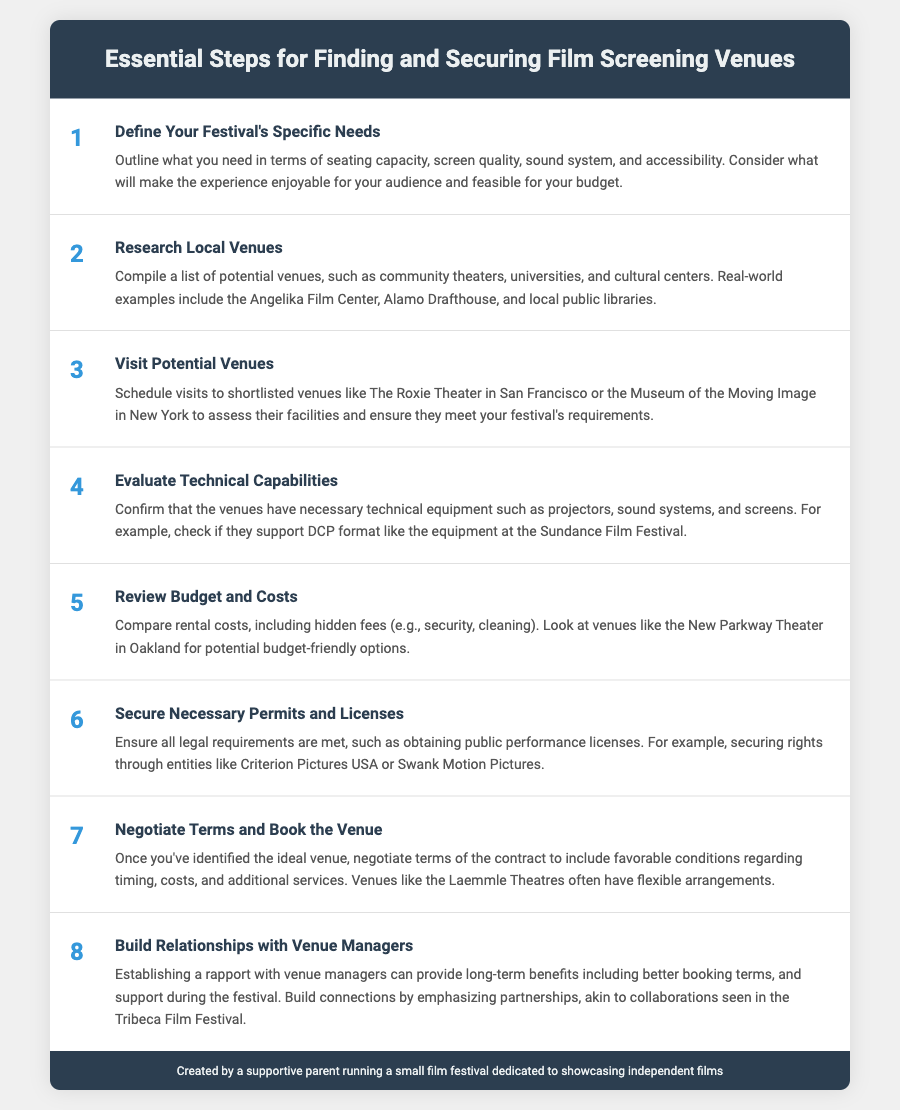What is the first step in securing a film screening venue? The first step listed is to "Define Your Festival's Specific Needs," which involves outlining requirements like seating capacity and sound systems.
Answer: Define Your Festival's Specific Needs Which venue is suggested for evaluating technical capabilities? The document mentions checking if venues support DCP format like the equipment at the Sundance Film Festival for evaluating technical capabilities.
Answer: Sundance Film Festival How many steps are outlined in the document? The document lists a total of eight steps for finding and securing film screening venues.
Answer: 8 What is emphasized as important when negotiating terms with a venue? Negotiating terms should include favorable conditions regarding timing, costs, and additional services, highlighting the importance of flexible arrangements.
Answer: Flexible arrangements What should be secured to meet legal requirements? The document indicates that necessary permits and licenses must be secured, particularly public performance licenses.
Answer: Public performance licenses Which venues were mentioned as potential options for budget-friendly screenings? The New Parkway Theater in Oakland is provided as an example of a budget-friendly venue.
Answer: New Parkway Theater What type of relationships should be built with venue managers? The document encourages building partnerships to establish rapport with venue managers for long-term benefits.
Answer: Partnerships What is the recommended action after visiting potential venues? After visiting, it's important to evaluate their facilities and determine if they meet the festival's requirements.
Answer: Evaluate their facilities 